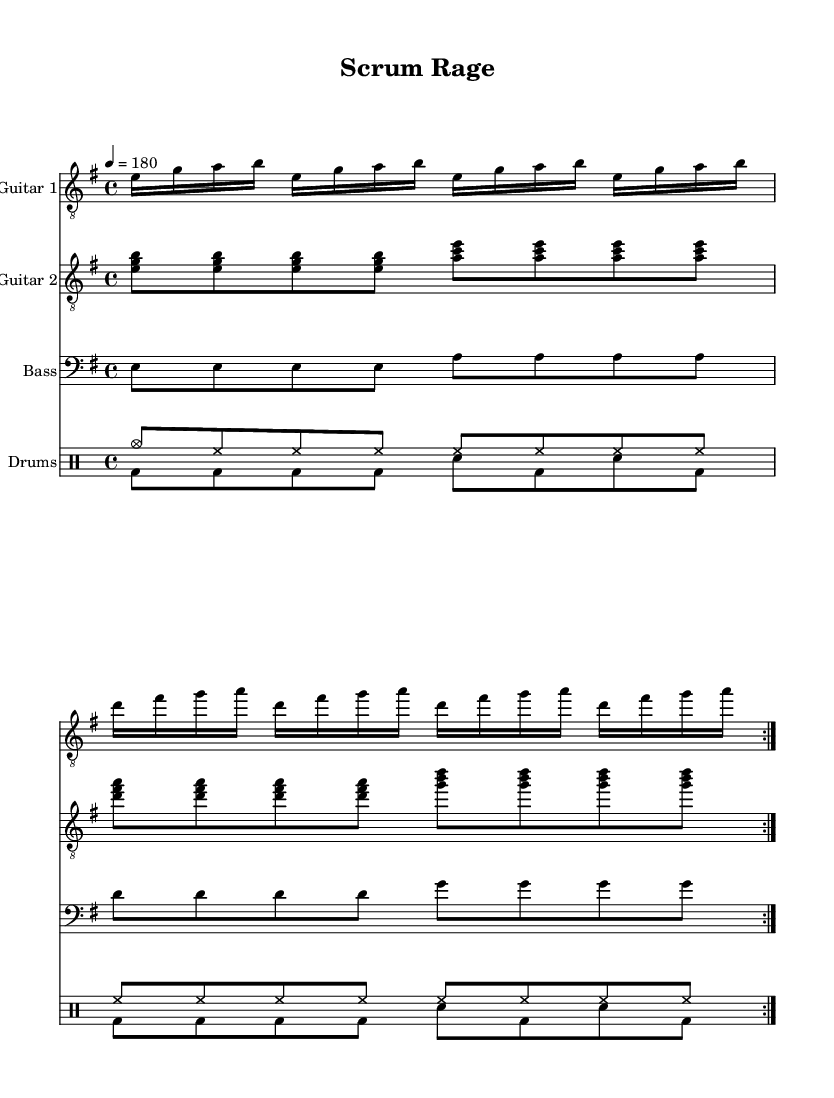What is the key signature of this music? The key signature is E minor, which has one sharp (F#). The presence of the F# indicates the key of E minor.
Answer: E minor What is the time signature of this piece? The time signature is 4/4, which means there are four beats in each measure, and each beat is a quarter note. This is evident from the notation at the beginning of the score.
Answer: 4/4 What is the tempo marking indicated in the score? The tempo marking is quarter note = 180, which suggests a fast pace for the piece. This is typically found at the beginning of the score.
Answer: 180 How many measures are repeated in the score? There are two measures that are repeated for both guitars, bass, and drums, as indicated by the "repeat volta 2" markings throughout the score.
Answer: 2 What instruments are included in this score? The score includes guitar 1, guitar 2, bass, and drums. This can be identified by the labels provided at the beginning of each corresponding staff.
Answer: Guitar 1, Guitar 2, Bass, Drums What type of rhythmic pattern is predominantly used in the guitar part? The predominant rhythmic pattern in the guitar part is sixteenth notes, indicated by the use of the "e16" notation. This suggests fast-paced playing typical of thrash metal.
Answer: Sixteenth notes 